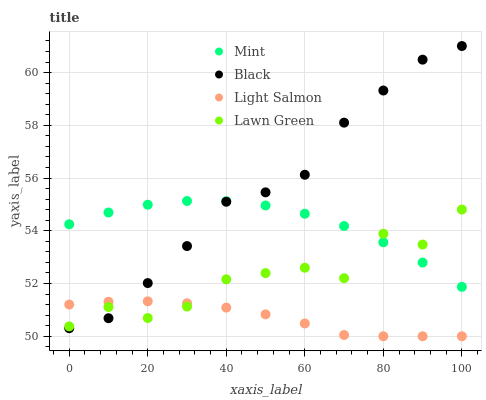Does Light Salmon have the minimum area under the curve?
Answer yes or no. Yes. Does Black have the maximum area under the curve?
Answer yes or no. Yes. Does Mint have the minimum area under the curve?
Answer yes or no. No. Does Mint have the maximum area under the curve?
Answer yes or no. No. Is Light Salmon the smoothest?
Answer yes or no. Yes. Is Lawn Green the roughest?
Answer yes or no. Yes. Is Mint the smoothest?
Answer yes or no. No. Is Mint the roughest?
Answer yes or no. No. Does Light Salmon have the lowest value?
Answer yes or no. Yes. Does Mint have the lowest value?
Answer yes or no. No. Does Black have the highest value?
Answer yes or no. Yes. Does Mint have the highest value?
Answer yes or no. No. Is Light Salmon less than Mint?
Answer yes or no. Yes. Is Mint greater than Light Salmon?
Answer yes or no. Yes. Does Black intersect Mint?
Answer yes or no. Yes. Is Black less than Mint?
Answer yes or no. No. Is Black greater than Mint?
Answer yes or no. No. Does Light Salmon intersect Mint?
Answer yes or no. No. 